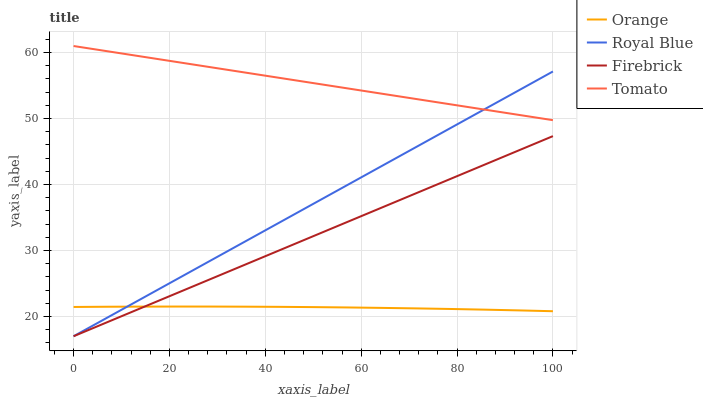Does Royal Blue have the minimum area under the curve?
Answer yes or no. No. Does Royal Blue have the maximum area under the curve?
Answer yes or no. No. Is Royal Blue the smoothest?
Answer yes or no. No. Is Royal Blue the roughest?
Answer yes or no. No. Does Tomato have the lowest value?
Answer yes or no. No. Does Royal Blue have the highest value?
Answer yes or no. No. Is Orange less than Tomato?
Answer yes or no. Yes. Is Tomato greater than Firebrick?
Answer yes or no. Yes. Does Orange intersect Tomato?
Answer yes or no. No. 